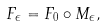Convert formula to latex. <formula><loc_0><loc_0><loc_500><loc_500>F _ { \epsilon } = F _ { 0 } \circ M _ { \epsilon } ,</formula> 